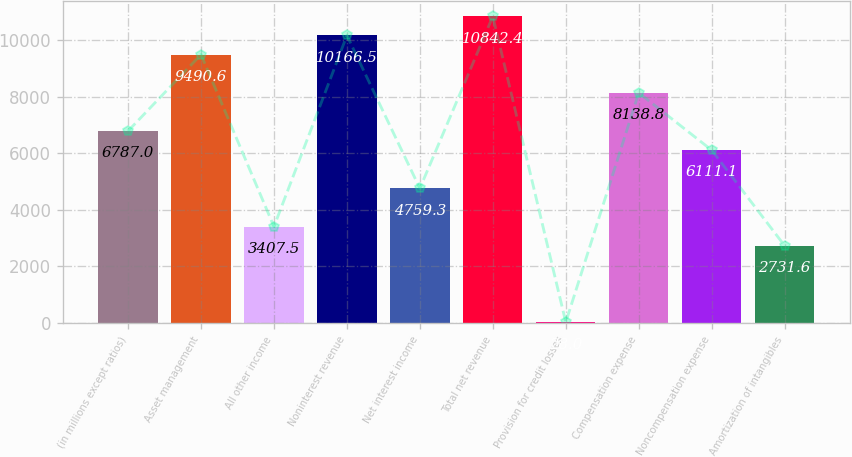<chart> <loc_0><loc_0><loc_500><loc_500><bar_chart><fcel>(in millions except ratios)<fcel>Asset management<fcel>All other income<fcel>Noninterest revenue<fcel>Net interest income<fcel>Total net revenue<fcel>Provision for credit losses<fcel>Compensation expense<fcel>Noncompensation expense<fcel>Amortization of intangibles<nl><fcel>6787<fcel>9490.6<fcel>3407.5<fcel>10166.5<fcel>4759.3<fcel>10842.4<fcel>28<fcel>8138.8<fcel>6111.1<fcel>2731.6<nl></chart> 